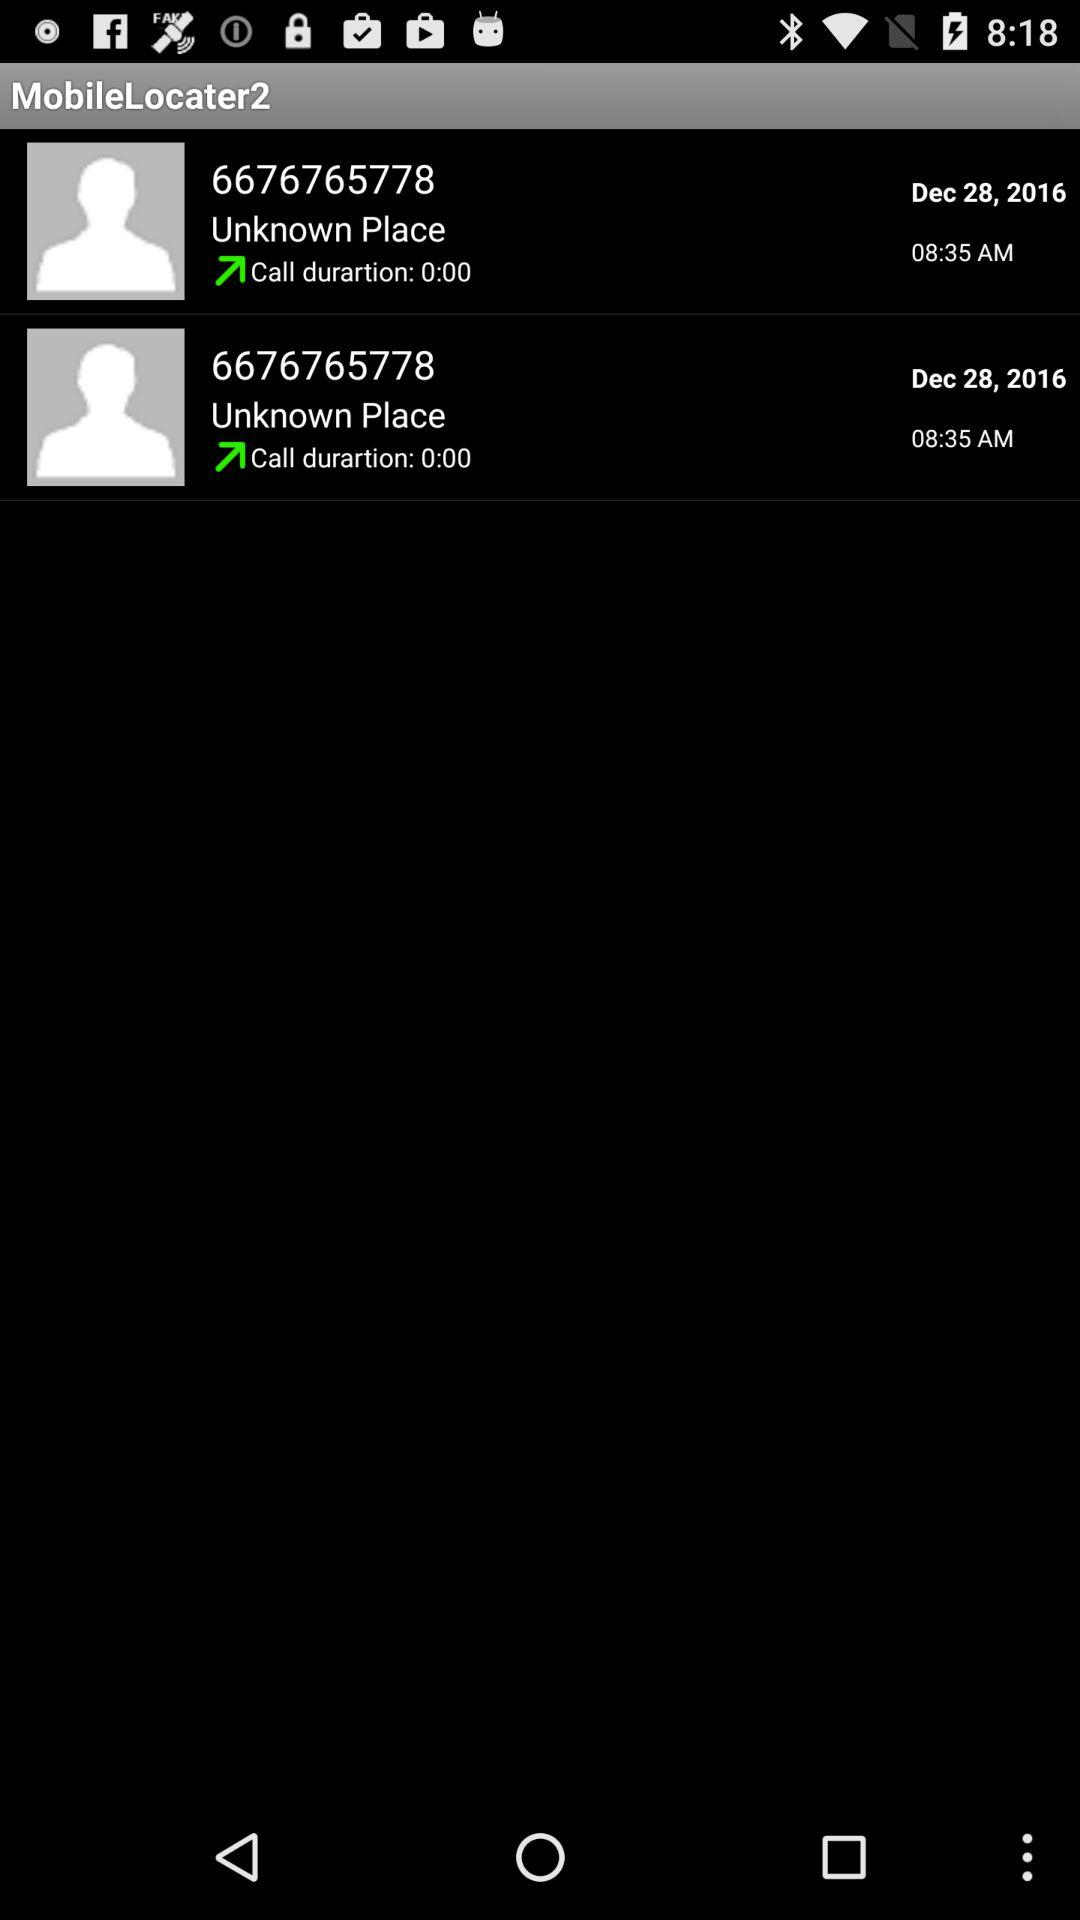What was the time when 6676765778 was called? 6676765778 was called at 8:35 AM. 